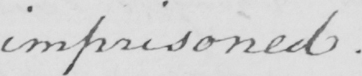What is written in this line of handwriting? imprisoned . 